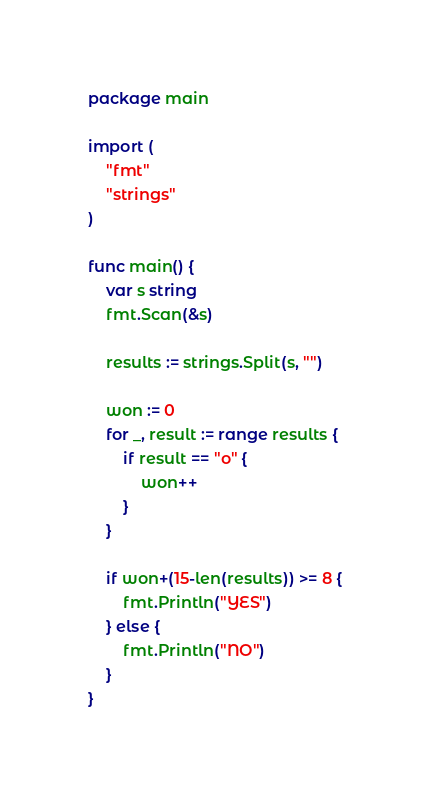<code> <loc_0><loc_0><loc_500><loc_500><_Go_>package main

import (
	"fmt"
	"strings"
)

func main() {
	var s string
	fmt.Scan(&s)

	results := strings.Split(s, "")

	won := 0
	for _, result := range results {
		if result == "o" {
			won++
		}
	}

	if won+(15-len(results)) >= 8 {
		fmt.Println("YES")
	} else {
		fmt.Println("NO")
	}
}
</code> 